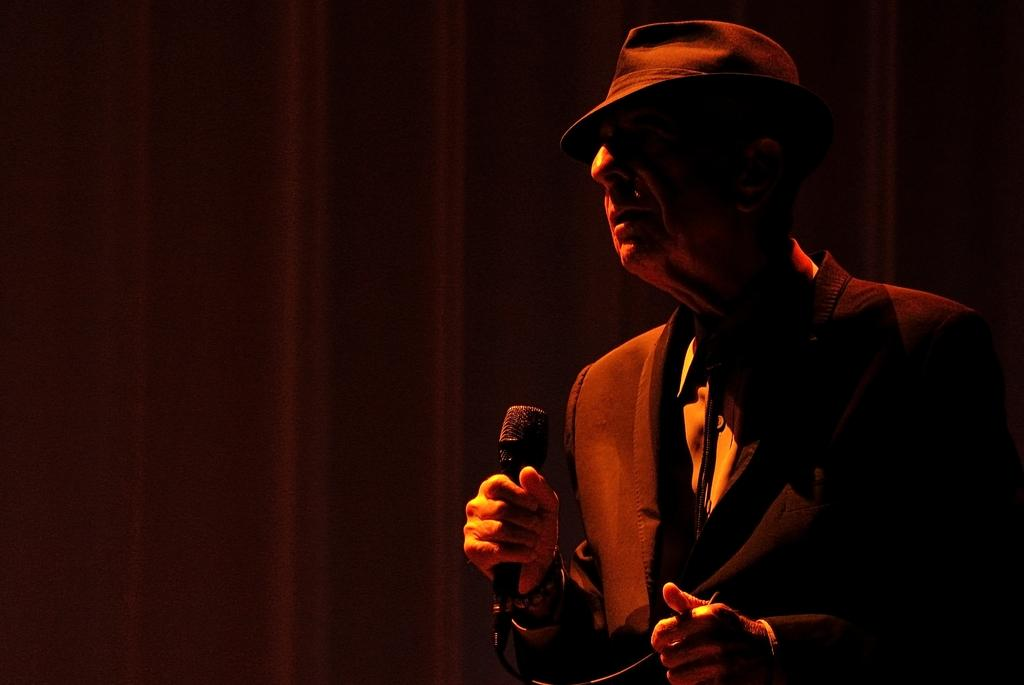Who is the main subject in the image? There is a man in the image. Where is the man located in the image? The man is on the right side of the image. What is the man holding in the image? The man is holding a mic. What is the color of the background in the image? The background of the image is dark. What type of calculator can be seen on the man's foot in the image? There is no calculator present on the man's foot in the image. What impulse might the man be experiencing while holding the mic in the image? The provided facts do not give any information about the man's emotions or impulses, so we cannot determine what impulse he might be experiencing. 